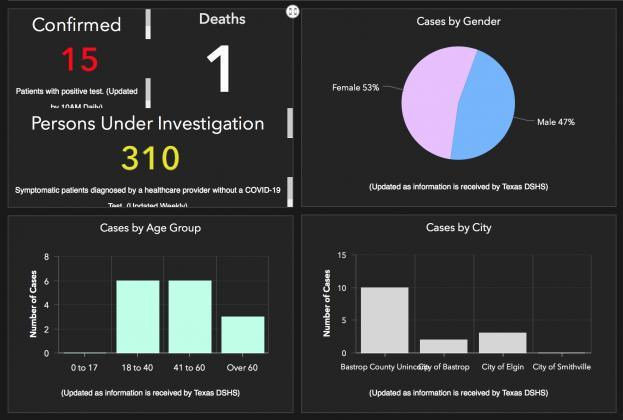How many asymptomatic patients are under investigation
Answer the question with a short phrase. 310 Which city is the second highest affected City of Elgin What is the colour of the confirmed case count, red or white red Which city has been the least affected City of Smithville Which age groups have been the most highly affected 18 to 40, 41 to 60 Which gender have been more affected by Covid-19 female 